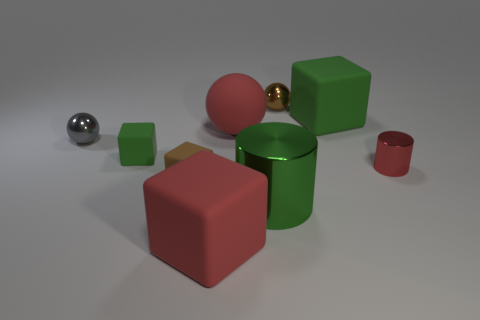Subtract all large red cubes. How many cubes are left? 3 Subtract all brown blocks. How many blocks are left? 3 Subtract all cyan cubes. Subtract all yellow spheres. How many cubes are left? 4 Subtract all balls. How many objects are left? 6 Subtract 1 red spheres. How many objects are left? 8 Subtract all big green cylinders. Subtract all large red matte balls. How many objects are left? 7 Add 8 metal spheres. How many metal spheres are left? 10 Add 2 metallic spheres. How many metallic spheres exist? 4 